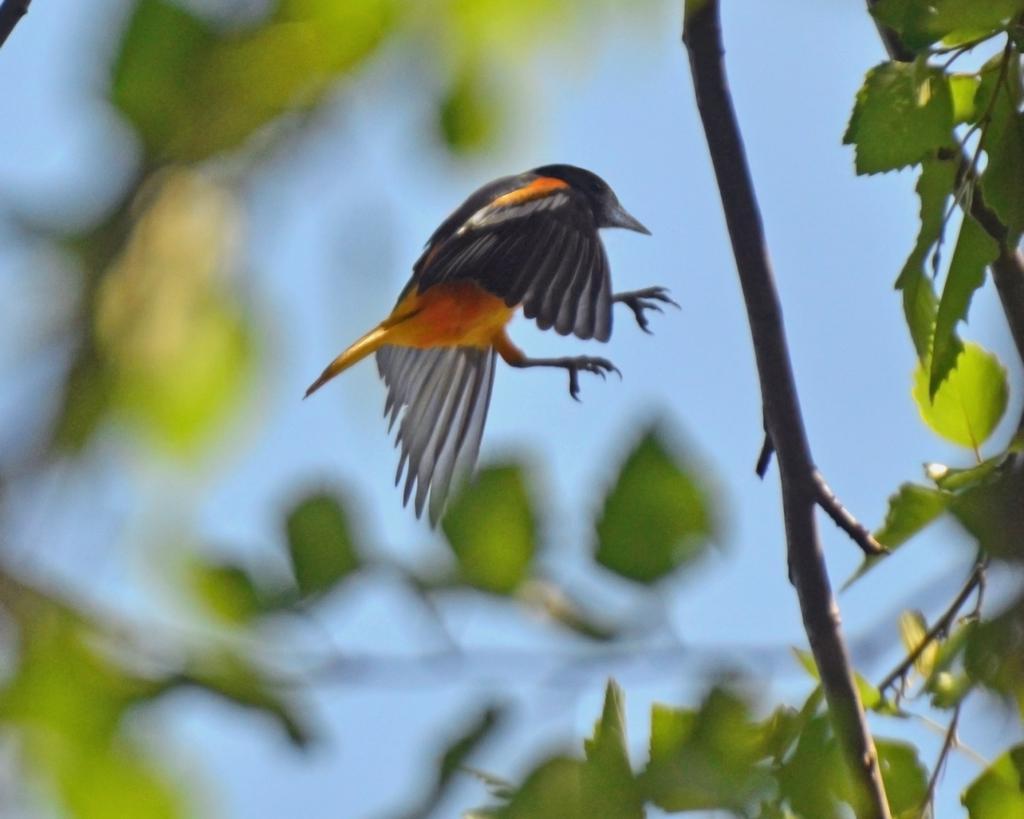Can you describe this image briefly? In the center of the image we can see bird in the sky. In the foreground we can see tree. 